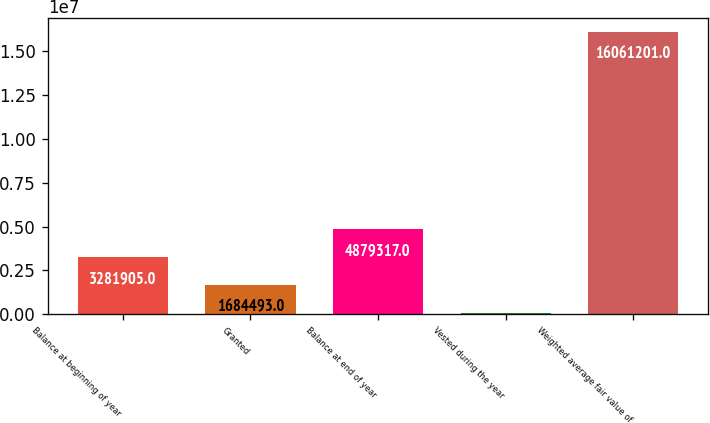<chart> <loc_0><loc_0><loc_500><loc_500><bar_chart><fcel>Balance at beginning of year<fcel>Granted<fcel>Balance at end of year<fcel>Vested during the year<fcel>Weighted average fair value of<nl><fcel>3.2819e+06<fcel>1.68449e+06<fcel>4.87932e+06<fcel>87081<fcel>1.60612e+07<nl></chart> 